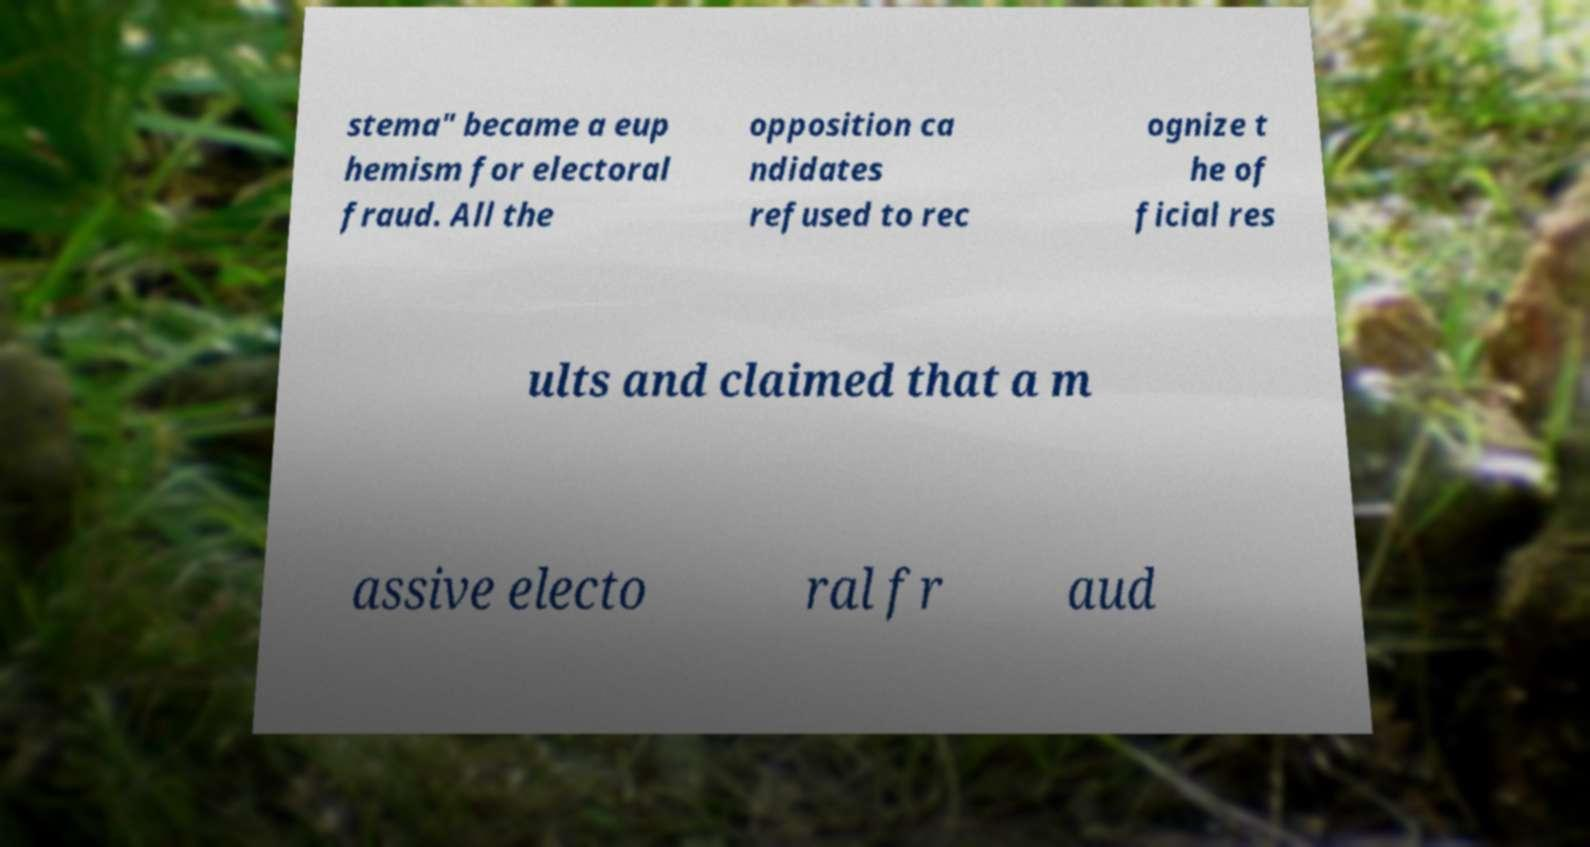There's text embedded in this image that I need extracted. Can you transcribe it verbatim? stema" became a eup hemism for electoral fraud. All the opposition ca ndidates refused to rec ognize t he of ficial res ults and claimed that a m assive electo ral fr aud 